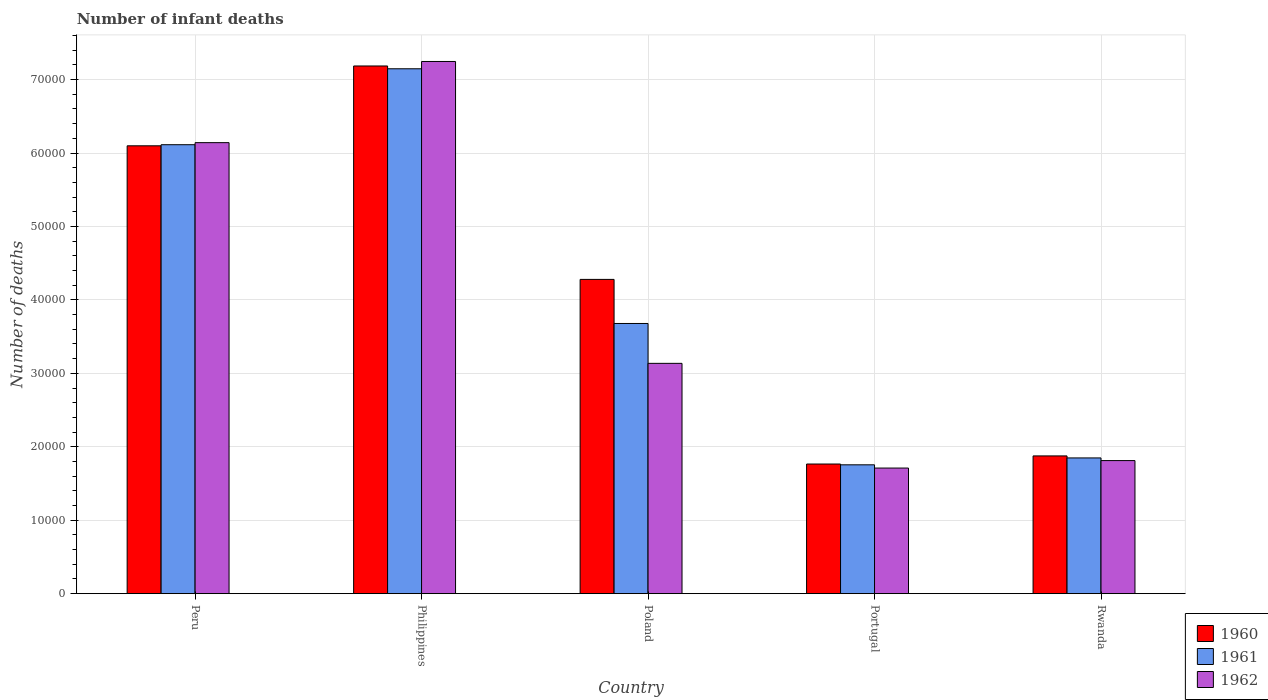How many groups of bars are there?
Ensure brevity in your answer.  5. Are the number of bars per tick equal to the number of legend labels?
Offer a very short reply. Yes. How many bars are there on the 2nd tick from the right?
Your answer should be very brief. 3. What is the label of the 4th group of bars from the left?
Keep it short and to the point. Portugal. What is the number of infant deaths in 1961 in Rwanda?
Your response must be concise. 1.85e+04. Across all countries, what is the maximum number of infant deaths in 1962?
Your answer should be compact. 7.25e+04. Across all countries, what is the minimum number of infant deaths in 1960?
Your response must be concise. 1.77e+04. In which country was the number of infant deaths in 1961 maximum?
Give a very brief answer. Philippines. In which country was the number of infant deaths in 1961 minimum?
Your response must be concise. Portugal. What is the total number of infant deaths in 1961 in the graph?
Keep it short and to the point. 2.05e+05. What is the difference between the number of infant deaths in 1961 in Peru and that in Poland?
Offer a terse response. 2.43e+04. What is the difference between the number of infant deaths in 1962 in Philippines and the number of infant deaths in 1961 in Portugal?
Give a very brief answer. 5.49e+04. What is the average number of infant deaths in 1961 per country?
Offer a terse response. 4.11e+04. What is the difference between the number of infant deaths of/in 1961 and number of infant deaths of/in 1960 in Portugal?
Ensure brevity in your answer.  -109. What is the ratio of the number of infant deaths in 1962 in Peru to that in Poland?
Offer a terse response. 1.96. What is the difference between the highest and the second highest number of infant deaths in 1960?
Give a very brief answer. 1.09e+04. What is the difference between the highest and the lowest number of infant deaths in 1961?
Give a very brief answer. 5.39e+04. What does the 2nd bar from the right in Philippines represents?
Your answer should be very brief. 1961. Is it the case that in every country, the sum of the number of infant deaths in 1961 and number of infant deaths in 1960 is greater than the number of infant deaths in 1962?
Your answer should be very brief. Yes. How many countries are there in the graph?
Keep it short and to the point. 5. Are the values on the major ticks of Y-axis written in scientific E-notation?
Keep it short and to the point. No. How many legend labels are there?
Provide a succinct answer. 3. What is the title of the graph?
Make the answer very short. Number of infant deaths. What is the label or title of the X-axis?
Give a very brief answer. Country. What is the label or title of the Y-axis?
Keep it short and to the point. Number of deaths. What is the Number of deaths in 1960 in Peru?
Offer a very short reply. 6.10e+04. What is the Number of deaths in 1961 in Peru?
Your answer should be very brief. 6.11e+04. What is the Number of deaths in 1962 in Peru?
Ensure brevity in your answer.  6.14e+04. What is the Number of deaths of 1960 in Philippines?
Offer a very short reply. 7.18e+04. What is the Number of deaths in 1961 in Philippines?
Your response must be concise. 7.15e+04. What is the Number of deaths of 1962 in Philippines?
Give a very brief answer. 7.25e+04. What is the Number of deaths in 1960 in Poland?
Your response must be concise. 4.28e+04. What is the Number of deaths of 1961 in Poland?
Offer a very short reply. 3.68e+04. What is the Number of deaths of 1962 in Poland?
Your answer should be very brief. 3.14e+04. What is the Number of deaths of 1960 in Portugal?
Provide a short and direct response. 1.77e+04. What is the Number of deaths in 1961 in Portugal?
Offer a terse response. 1.75e+04. What is the Number of deaths in 1962 in Portugal?
Ensure brevity in your answer.  1.71e+04. What is the Number of deaths in 1960 in Rwanda?
Provide a succinct answer. 1.88e+04. What is the Number of deaths in 1961 in Rwanda?
Offer a very short reply. 1.85e+04. What is the Number of deaths in 1962 in Rwanda?
Make the answer very short. 1.81e+04. Across all countries, what is the maximum Number of deaths in 1960?
Your answer should be compact. 7.18e+04. Across all countries, what is the maximum Number of deaths of 1961?
Your response must be concise. 7.15e+04. Across all countries, what is the maximum Number of deaths of 1962?
Make the answer very short. 7.25e+04. Across all countries, what is the minimum Number of deaths of 1960?
Offer a very short reply. 1.77e+04. Across all countries, what is the minimum Number of deaths in 1961?
Your answer should be compact. 1.75e+04. Across all countries, what is the minimum Number of deaths in 1962?
Ensure brevity in your answer.  1.71e+04. What is the total Number of deaths of 1960 in the graph?
Give a very brief answer. 2.12e+05. What is the total Number of deaths of 1961 in the graph?
Keep it short and to the point. 2.05e+05. What is the total Number of deaths of 1962 in the graph?
Make the answer very short. 2.00e+05. What is the difference between the Number of deaths of 1960 in Peru and that in Philippines?
Your answer should be very brief. -1.09e+04. What is the difference between the Number of deaths in 1961 in Peru and that in Philippines?
Offer a very short reply. -1.03e+04. What is the difference between the Number of deaths of 1962 in Peru and that in Philippines?
Provide a succinct answer. -1.11e+04. What is the difference between the Number of deaths of 1960 in Peru and that in Poland?
Your answer should be very brief. 1.82e+04. What is the difference between the Number of deaths in 1961 in Peru and that in Poland?
Provide a succinct answer. 2.43e+04. What is the difference between the Number of deaths in 1962 in Peru and that in Poland?
Offer a very short reply. 3.01e+04. What is the difference between the Number of deaths of 1960 in Peru and that in Portugal?
Make the answer very short. 4.33e+04. What is the difference between the Number of deaths in 1961 in Peru and that in Portugal?
Give a very brief answer. 4.36e+04. What is the difference between the Number of deaths in 1962 in Peru and that in Portugal?
Give a very brief answer. 4.43e+04. What is the difference between the Number of deaths of 1960 in Peru and that in Rwanda?
Your response must be concise. 4.22e+04. What is the difference between the Number of deaths of 1961 in Peru and that in Rwanda?
Offer a very short reply. 4.26e+04. What is the difference between the Number of deaths in 1962 in Peru and that in Rwanda?
Keep it short and to the point. 4.33e+04. What is the difference between the Number of deaths in 1960 in Philippines and that in Poland?
Give a very brief answer. 2.91e+04. What is the difference between the Number of deaths in 1961 in Philippines and that in Poland?
Make the answer very short. 3.47e+04. What is the difference between the Number of deaths of 1962 in Philippines and that in Poland?
Make the answer very short. 4.11e+04. What is the difference between the Number of deaths of 1960 in Philippines and that in Portugal?
Offer a terse response. 5.42e+04. What is the difference between the Number of deaths of 1961 in Philippines and that in Portugal?
Your answer should be very brief. 5.39e+04. What is the difference between the Number of deaths of 1962 in Philippines and that in Portugal?
Keep it short and to the point. 5.54e+04. What is the difference between the Number of deaths in 1960 in Philippines and that in Rwanda?
Provide a short and direct response. 5.31e+04. What is the difference between the Number of deaths of 1961 in Philippines and that in Rwanda?
Ensure brevity in your answer.  5.30e+04. What is the difference between the Number of deaths of 1962 in Philippines and that in Rwanda?
Offer a very short reply. 5.43e+04. What is the difference between the Number of deaths in 1960 in Poland and that in Portugal?
Your answer should be very brief. 2.51e+04. What is the difference between the Number of deaths in 1961 in Poland and that in Portugal?
Make the answer very short. 1.92e+04. What is the difference between the Number of deaths of 1962 in Poland and that in Portugal?
Offer a terse response. 1.43e+04. What is the difference between the Number of deaths of 1960 in Poland and that in Rwanda?
Give a very brief answer. 2.40e+04. What is the difference between the Number of deaths of 1961 in Poland and that in Rwanda?
Offer a terse response. 1.83e+04. What is the difference between the Number of deaths of 1962 in Poland and that in Rwanda?
Give a very brief answer. 1.32e+04. What is the difference between the Number of deaths of 1960 in Portugal and that in Rwanda?
Keep it short and to the point. -1103. What is the difference between the Number of deaths of 1961 in Portugal and that in Rwanda?
Ensure brevity in your answer.  -939. What is the difference between the Number of deaths of 1962 in Portugal and that in Rwanda?
Your response must be concise. -1018. What is the difference between the Number of deaths in 1960 in Peru and the Number of deaths in 1961 in Philippines?
Offer a very short reply. -1.05e+04. What is the difference between the Number of deaths in 1960 in Peru and the Number of deaths in 1962 in Philippines?
Offer a terse response. -1.15e+04. What is the difference between the Number of deaths in 1961 in Peru and the Number of deaths in 1962 in Philippines?
Offer a very short reply. -1.13e+04. What is the difference between the Number of deaths in 1960 in Peru and the Number of deaths in 1961 in Poland?
Make the answer very short. 2.42e+04. What is the difference between the Number of deaths of 1960 in Peru and the Number of deaths of 1962 in Poland?
Your response must be concise. 2.96e+04. What is the difference between the Number of deaths of 1961 in Peru and the Number of deaths of 1962 in Poland?
Give a very brief answer. 2.98e+04. What is the difference between the Number of deaths of 1960 in Peru and the Number of deaths of 1961 in Portugal?
Your answer should be very brief. 4.34e+04. What is the difference between the Number of deaths in 1960 in Peru and the Number of deaths in 1962 in Portugal?
Offer a terse response. 4.39e+04. What is the difference between the Number of deaths of 1961 in Peru and the Number of deaths of 1962 in Portugal?
Offer a very short reply. 4.40e+04. What is the difference between the Number of deaths in 1960 in Peru and the Number of deaths in 1961 in Rwanda?
Provide a short and direct response. 4.25e+04. What is the difference between the Number of deaths in 1960 in Peru and the Number of deaths in 1962 in Rwanda?
Provide a succinct answer. 4.29e+04. What is the difference between the Number of deaths of 1961 in Peru and the Number of deaths of 1962 in Rwanda?
Ensure brevity in your answer.  4.30e+04. What is the difference between the Number of deaths of 1960 in Philippines and the Number of deaths of 1961 in Poland?
Provide a succinct answer. 3.51e+04. What is the difference between the Number of deaths in 1960 in Philippines and the Number of deaths in 1962 in Poland?
Keep it short and to the point. 4.05e+04. What is the difference between the Number of deaths in 1961 in Philippines and the Number of deaths in 1962 in Poland?
Keep it short and to the point. 4.01e+04. What is the difference between the Number of deaths of 1960 in Philippines and the Number of deaths of 1961 in Portugal?
Provide a short and direct response. 5.43e+04. What is the difference between the Number of deaths of 1960 in Philippines and the Number of deaths of 1962 in Portugal?
Offer a very short reply. 5.47e+04. What is the difference between the Number of deaths in 1961 in Philippines and the Number of deaths in 1962 in Portugal?
Make the answer very short. 5.44e+04. What is the difference between the Number of deaths of 1960 in Philippines and the Number of deaths of 1961 in Rwanda?
Your answer should be very brief. 5.34e+04. What is the difference between the Number of deaths of 1960 in Philippines and the Number of deaths of 1962 in Rwanda?
Your answer should be very brief. 5.37e+04. What is the difference between the Number of deaths of 1961 in Philippines and the Number of deaths of 1962 in Rwanda?
Make the answer very short. 5.34e+04. What is the difference between the Number of deaths of 1960 in Poland and the Number of deaths of 1961 in Portugal?
Ensure brevity in your answer.  2.52e+04. What is the difference between the Number of deaths in 1960 in Poland and the Number of deaths in 1962 in Portugal?
Make the answer very short. 2.57e+04. What is the difference between the Number of deaths of 1961 in Poland and the Number of deaths of 1962 in Portugal?
Your answer should be compact. 1.97e+04. What is the difference between the Number of deaths of 1960 in Poland and the Number of deaths of 1961 in Rwanda?
Provide a succinct answer. 2.43e+04. What is the difference between the Number of deaths of 1960 in Poland and the Number of deaths of 1962 in Rwanda?
Provide a succinct answer. 2.47e+04. What is the difference between the Number of deaths in 1961 in Poland and the Number of deaths in 1962 in Rwanda?
Ensure brevity in your answer.  1.87e+04. What is the difference between the Number of deaths in 1960 in Portugal and the Number of deaths in 1961 in Rwanda?
Offer a terse response. -830. What is the difference between the Number of deaths of 1960 in Portugal and the Number of deaths of 1962 in Rwanda?
Offer a very short reply. -468. What is the difference between the Number of deaths in 1961 in Portugal and the Number of deaths in 1962 in Rwanda?
Give a very brief answer. -577. What is the average Number of deaths in 1960 per country?
Ensure brevity in your answer.  4.24e+04. What is the average Number of deaths in 1961 per country?
Your response must be concise. 4.11e+04. What is the average Number of deaths of 1962 per country?
Make the answer very short. 4.01e+04. What is the difference between the Number of deaths in 1960 and Number of deaths in 1961 in Peru?
Offer a terse response. -149. What is the difference between the Number of deaths in 1960 and Number of deaths in 1962 in Peru?
Your response must be concise. -431. What is the difference between the Number of deaths in 1961 and Number of deaths in 1962 in Peru?
Ensure brevity in your answer.  -282. What is the difference between the Number of deaths of 1960 and Number of deaths of 1961 in Philippines?
Provide a short and direct response. 380. What is the difference between the Number of deaths in 1960 and Number of deaths in 1962 in Philippines?
Make the answer very short. -612. What is the difference between the Number of deaths in 1961 and Number of deaths in 1962 in Philippines?
Offer a terse response. -992. What is the difference between the Number of deaths in 1960 and Number of deaths in 1961 in Poland?
Your answer should be compact. 6002. What is the difference between the Number of deaths in 1960 and Number of deaths in 1962 in Poland?
Provide a succinct answer. 1.14e+04. What is the difference between the Number of deaths of 1961 and Number of deaths of 1962 in Poland?
Keep it short and to the point. 5430. What is the difference between the Number of deaths of 1960 and Number of deaths of 1961 in Portugal?
Make the answer very short. 109. What is the difference between the Number of deaths of 1960 and Number of deaths of 1962 in Portugal?
Ensure brevity in your answer.  550. What is the difference between the Number of deaths of 1961 and Number of deaths of 1962 in Portugal?
Make the answer very short. 441. What is the difference between the Number of deaths of 1960 and Number of deaths of 1961 in Rwanda?
Your answer should be compact. 273. What is the difference between the Number of deaths in 1960 and Number of deaths in 1962 in Rwanda?
Your answer should be very brief. 635. What is the difference between the Number of deaths of 1961 and Number of deaths of 1962 in Rwanda?
Keep it short and to the point. 362. What is the ratio of the Number of deaths of 1960 in Peru to that in Philippines?
Your response must be concise. 0.85. What is the ratio of the Number of deaths of 1961 in Peru to that in Philippines?
Provide a succinct answer. 0.86. What is the ratio of the Number of deaths in 1962 in Peru to that in Philippines?
Give a very brief answer. 0.85. What is the ratio of the Number of deaths of 1960 in Peru to that in Poland?
Offer a terse response. 1.43. What is the ratio of the Number of deaths in 1961 in Peru to that in Poland?
Ensure brevity in your answer.  1.66. What is the ratio of the Number of deaths in 1962 in Peru to that in Poland?
Offer a terse response. 1.96. What is the ratio of the Number of deaths of 1960 in Peru to that in Portugal?
Give a very brief answer. 3.45. What is the ratio of the Number of deaths of 1961 in Peru to that in Portugal?
Give a very brief answer. 3.48. What is the ratio of the Number of deaths of 1962 in Peru to that in Portugal?
Your answer should be compact. 3.59. What is the ratio of the Number of deaths of 1960 in Peru to that in Rwanda?
Offer a very short reply. 3.25. What is the ratio of the Number of deaths of 1961 in Peru to that in Rwanda?
Your response must be concise. 3.31. What is the ratio of the Number of deaths in 1962 in Peru to that in Rwanda?
Ensure brevity in your answer.  3.39. What is the ratio of the Number of deaths of 1960 in Philippines to that in Poland?
Your response must be concise. 1.68. What is the ratio of the Number of deaths of 1961 in Philippines to that in Poland?
Make the answer very short. 1.94. What is the ratio of the Number of deaths of 1962 in Philippines to that in Poland?
Provide a succinct answer. 2.31. What is the ratio of the Number of deaths of 1960 in Philippines to that in Portugal?
Provide a short and direct response. 4.07. What is the ratio of the Number of deaths of 1961 in Philippines to that in Portugal?
Your answer should be compact. 4.07. What is the ratio of the Number of deaths in 1962 in Philippines to that in Portugal?
Your answer should be very brief. 4.24. What is the ratio of the Number of deaths in 1960 in Philippines to that in Rwanda?
Ensure brevity in your answer.  3.83. What is the ratio of the Number of deaths in 1961 in Philippines to that in Rwanda?
Provide a succinct answer. 3.87. What is the ratio of the Number of deaths in 1962 in Philippines to that in Rwanda?
Make the answer very short. 4. What is the ratio of the Number of deaths in 1960 in Poland to that in Portugal?
Provide a short and direct response. 2.42. What is the ratio of the Number of deaths of 1961 in Poland to that in Portugal?
Your answer should be very brief. 2.1. What is the ratio of the Number of deaths of 1962 in Poland to that in Portugal?
Offer a terse response. 1.83. What is the ratio of the Number of deaths in 1960 in Poland to that in Rwanda?
Make the answer very short. 2.28. What is the ratio of the Number of deaths in 1961 in Poland to that in Rwanda?
Offer a very short reply. 1.99. What is the ratio of the Number of deaths of 1962 in Poland to that in Rwanda?
Your response must be concise. 1.73. What is the ratio of the Number of deaths of 1960 in Portugal to that in Rwanda?
Your response must be concise. 0.94. What is the ratio of the Number of deaths in 1961 in Portugal to that in Rwanda?
Keep it short and to the point. 0.95. What is the ratio of the Number of deaths of 1962 in Portugal to that in Rwanda?
Make the answer very short. 0.94. What is the difference between the highest and the second highest Number of deaths in 1960?
Give a very brief answer. 1.09e+04. What is the difference between the highest and the second highest Number of deaths in 1961?
Offer a terse response. 1.03e+04. What is the difference between the highest and the second highest Number of deaths in 1962?
Provide a short and direct response. 1.11e+04. What is the difference between the highest and the lowest Number of deaths in 1960?
Give a very brief answer. 5.42e+04. What is the difference between the highest and the lowest Number of deaths in 1961?
Offer a very short reply. 5.39e+04. What is the difference between the highest and the lowest Number of deaths in 1962?
Your response must be concise. 5.54e+04. 